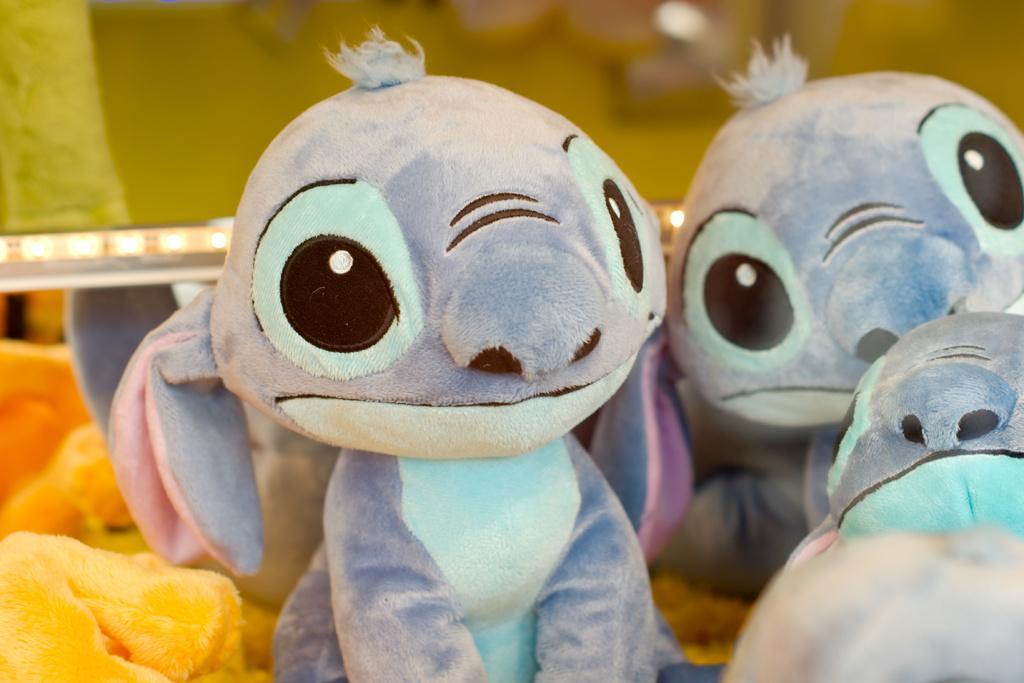Could you give a brief overview of what you see in this image? In this image in the middle, there are many toys. In the background there are lights and wall. 